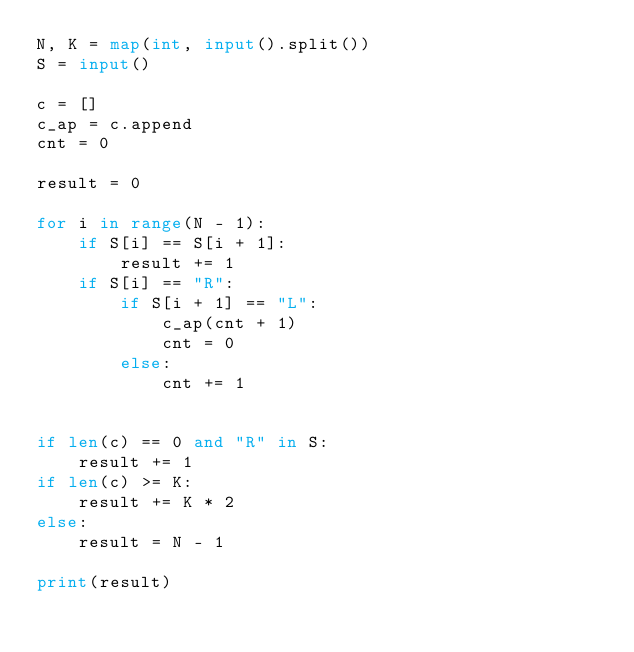Convert code to text. <code><loc_0><loc_0><loc_500><loc_500><_Python_>N, K = map(int, input().split())
S = input()

c = []
c_ap = c.append
cnt = 0

result = 0

for i in range(N - 1):
    if S[i] == S[i + 1]:
        result += 1
    if S[i] == "R":
        if S[i + 1] == "L":
            c_ap(cnt + 1)
            cnt = 0
        else:
            cnt += 1
            
            
if len(c) == 0 and "R" in S:
    result += 1
if len(c) >= K:
    result += K * 2
else:
    result = N - 1

print(result)
</code> 